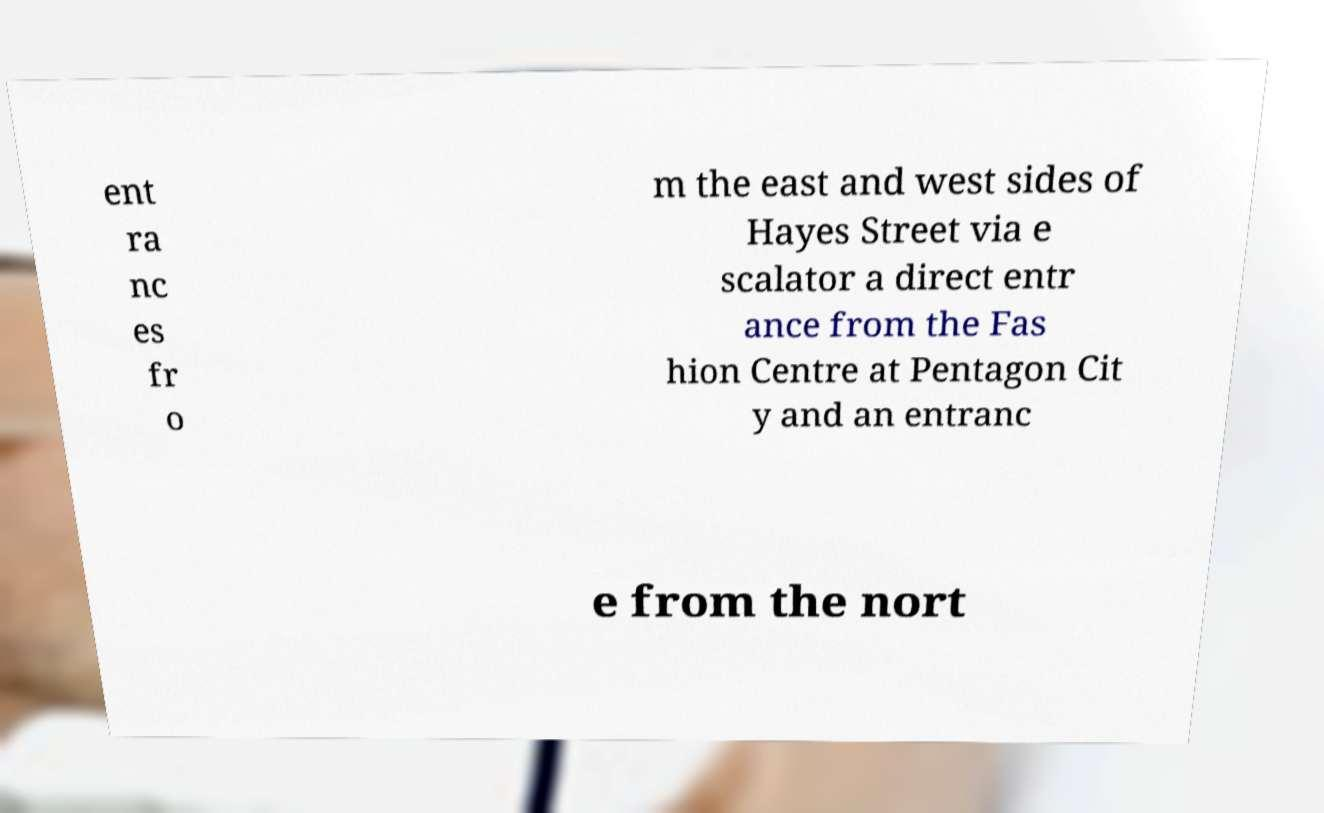Can you read and provide the text displayed in the image?This photo seems to have some interesting text. Can you extract and type it out for me? ent ra nc es fr o m the east and west sides of Hayes Street via e scalator a direct entr ance from the Fas hion Centre at Pentagon Cit y and an entranc e from the nort 